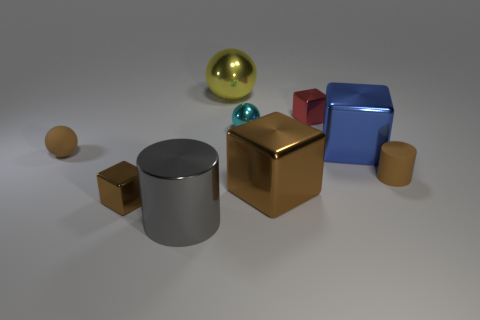Subtract all shiny balls. How many balls are left? 1 Subtract all yellow balls. How many balls are left? 2 Subtract all spheres. How many objects are left? 6 Subtract 1 spheres. How many spheres are left? 2 Subtract all red balls. Subtract all gray cylinders. How many balls are left? 3 Add 7 small cylinders. How many small cylinders are left? 8 Add 6 yellow objects. How many yellow objects exist? 7 Subtract 1 red cubes. How many objects are left? 8 Subtract all yellow spheres. How many brown cylinders are left? 1 Subtract all big blue metallic things. Subtract all blue objects. How many objects are left? 7 